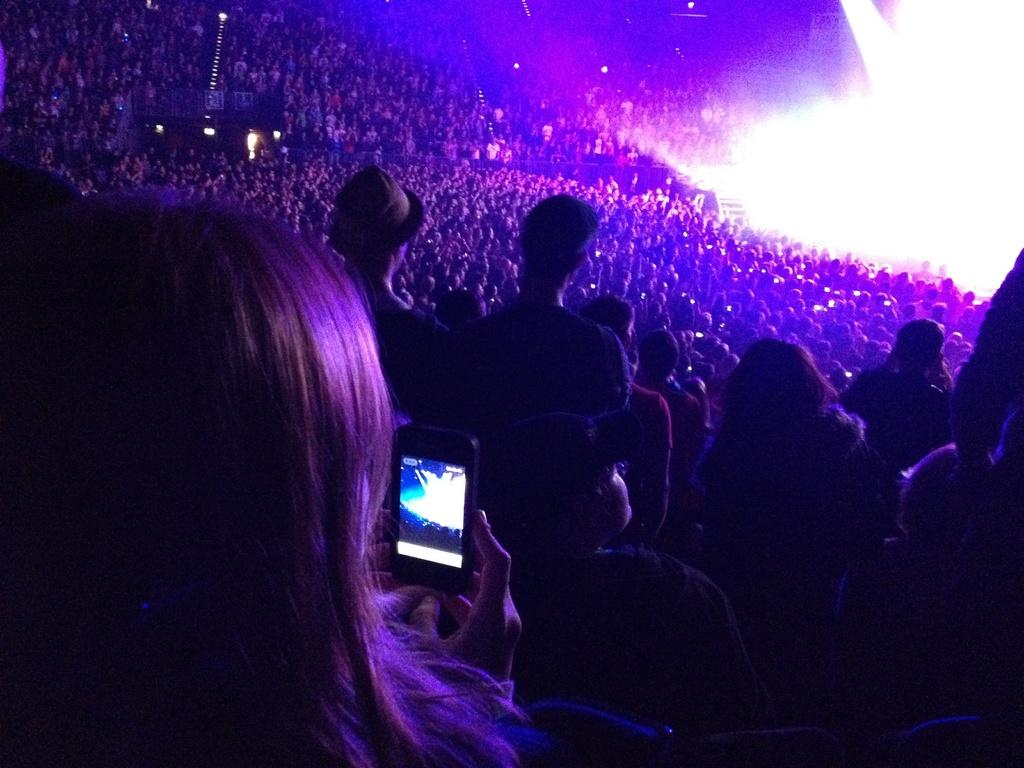What is the person in the image holding? The person in the image is holding a mobile phone. Where is the person in the image located? The person is in a stadium, as there are many people in the stadium in the image. What type of skate is being used by the person in the image? There is no skate present in the image; the person is holding a mobile phone in a stadium. 